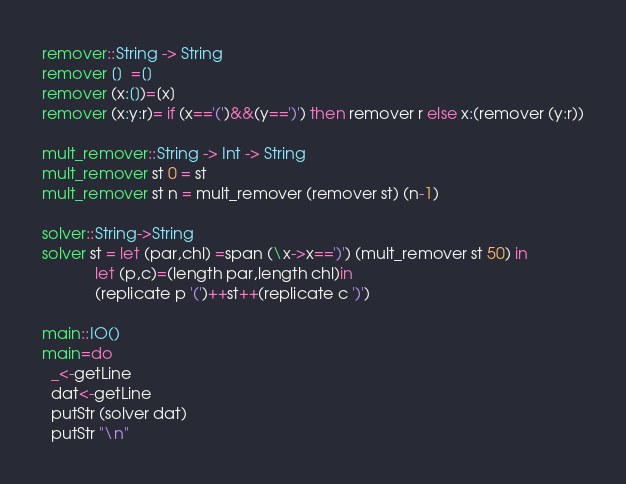Convert code to text. <code><loc_0><loc_0><loc_500><loc_500><_Haskell_>
remover::String -> String
remover []  =[]
remover (x:[])=[x]
remover (x:y:r)= if (x=='(')&&(y==')') then remover r else x:(remover (y:r))

mult_remover::String -> Int -> String
mult_remover st 0 = st
mult_remover st n = mult_remover (remover st) (n-1)

solver::String->String
solver st = let (par,chl) =span (\x->x==')') (mult_remover st 50) in
            let (p,c)=(length par,length chl)in
            (replicate p '(')++st++(replicate c ')')

main::IO()
main=do
  _<-getLine
  dat<-getLine
  putStr (solver dat)
  putStr "\n"</code> 